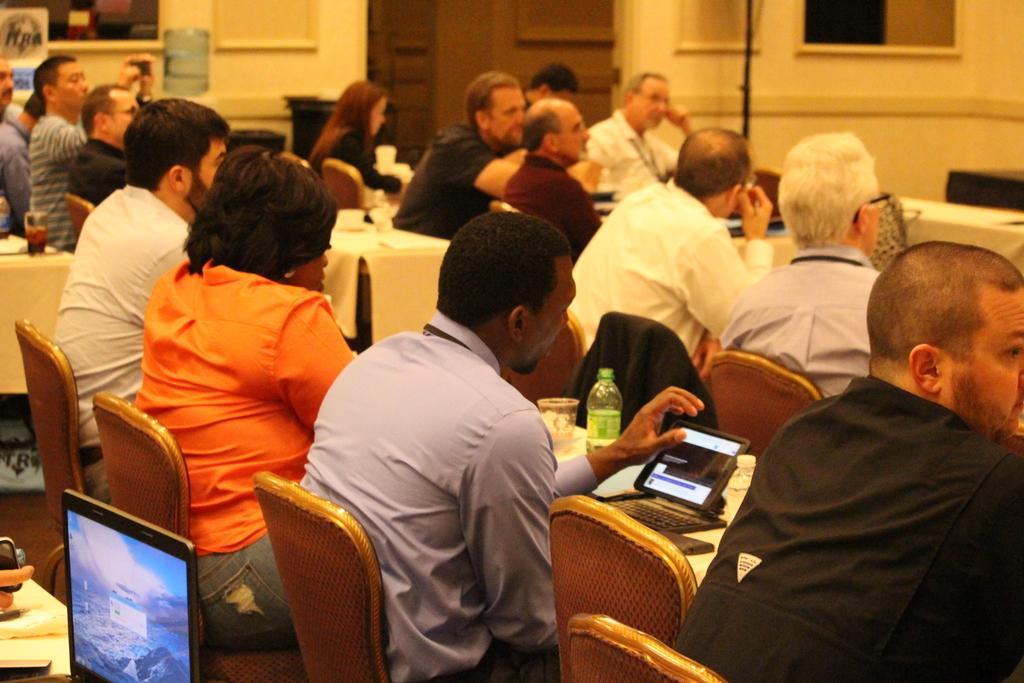How would you summarize this image in a sentence or two? In this picture we can see some persons sitting on the chairs. This is the table. On the table there is a laptop, bottle, and a glass. On the background there is a wall and this is the door. 